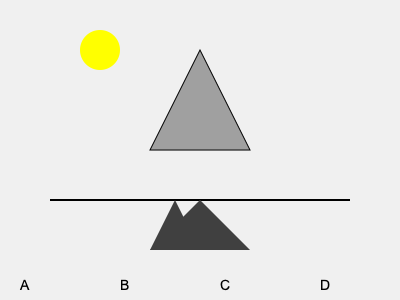In our old office, we used to conduct lighting experiments with various 3D objects. If a triangular prism is illuminated by a light source positioned at the top-left corner of the image, which of the shadows (A, B, C, or D) would most accurately represent its projection? To determine the correct shadow, we need to consider the following steps:

1. Light source position: The light is coming from the top-left corner, as indicated by the yellow circle.

2. Object orientation: The triangular prism is positioned with its base parallel to the ground and its point facing upwards.

3. Shadow formation principles:
   a) Shadows are cast in the opposite direction of the light source.
   b) The shape of the shadow depends on the object's orientation relative to the light source and the surface it's cast upon.

4. Analyzing the options:
   A: This shadow is not shown in the image.
   B: This shadow has two points, which doesn't match the prism's base shape.
   C: This shadow accurately represents the prism's base shape and orientation.
   D: This shadow is inverted compared to the prism's orientation.

5. Conclusion: Option C correctly represents the shadow cast by the triangular prism when illuminated from the top-left corner. The shadow maintains the triangular shape of the prism's base and is oriented in the opposite direction of the light source.
Answer: C 